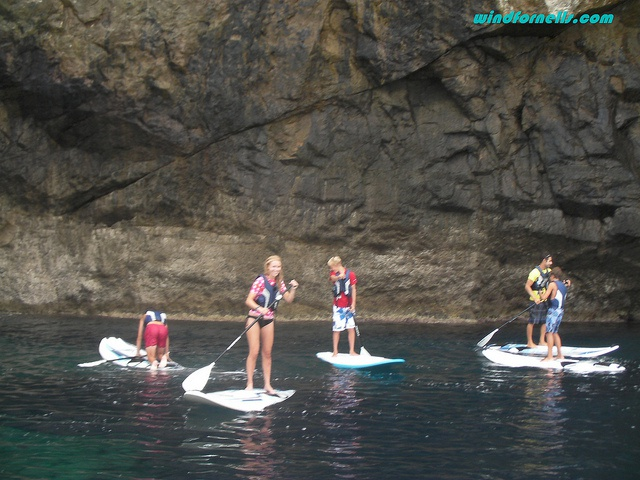Describe the objects in this image and their specific colors. I can see people in darkgreen, lightpink, lightgray, and gray tones, people in darkgreen, white, tan, gray, and brown tones, people in darkgreen, gray, khaki, and tan tones, people in darkgreen, white, tan, and brown tones, and surfboard in darkgreen, white, darkgray, gray, and lightblue tones in this image. 